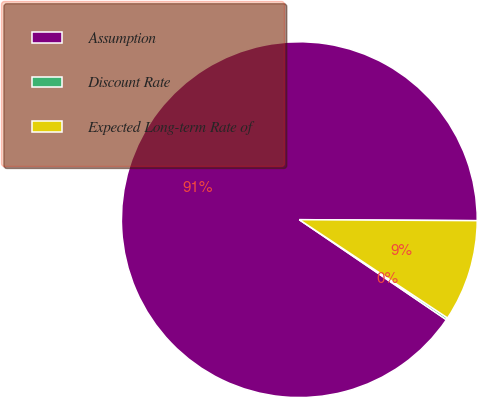Convert chart to OTSL. <chart><loc_0><loc_0><loc_500><loc_500><pie_chart><fcel>Assumption<fcel>Discount Rate<fcel>Expected Long-term Rate of<nl><fcel>90.58%<fcel>0.19%<fcel>9.23%<nl></chart> 